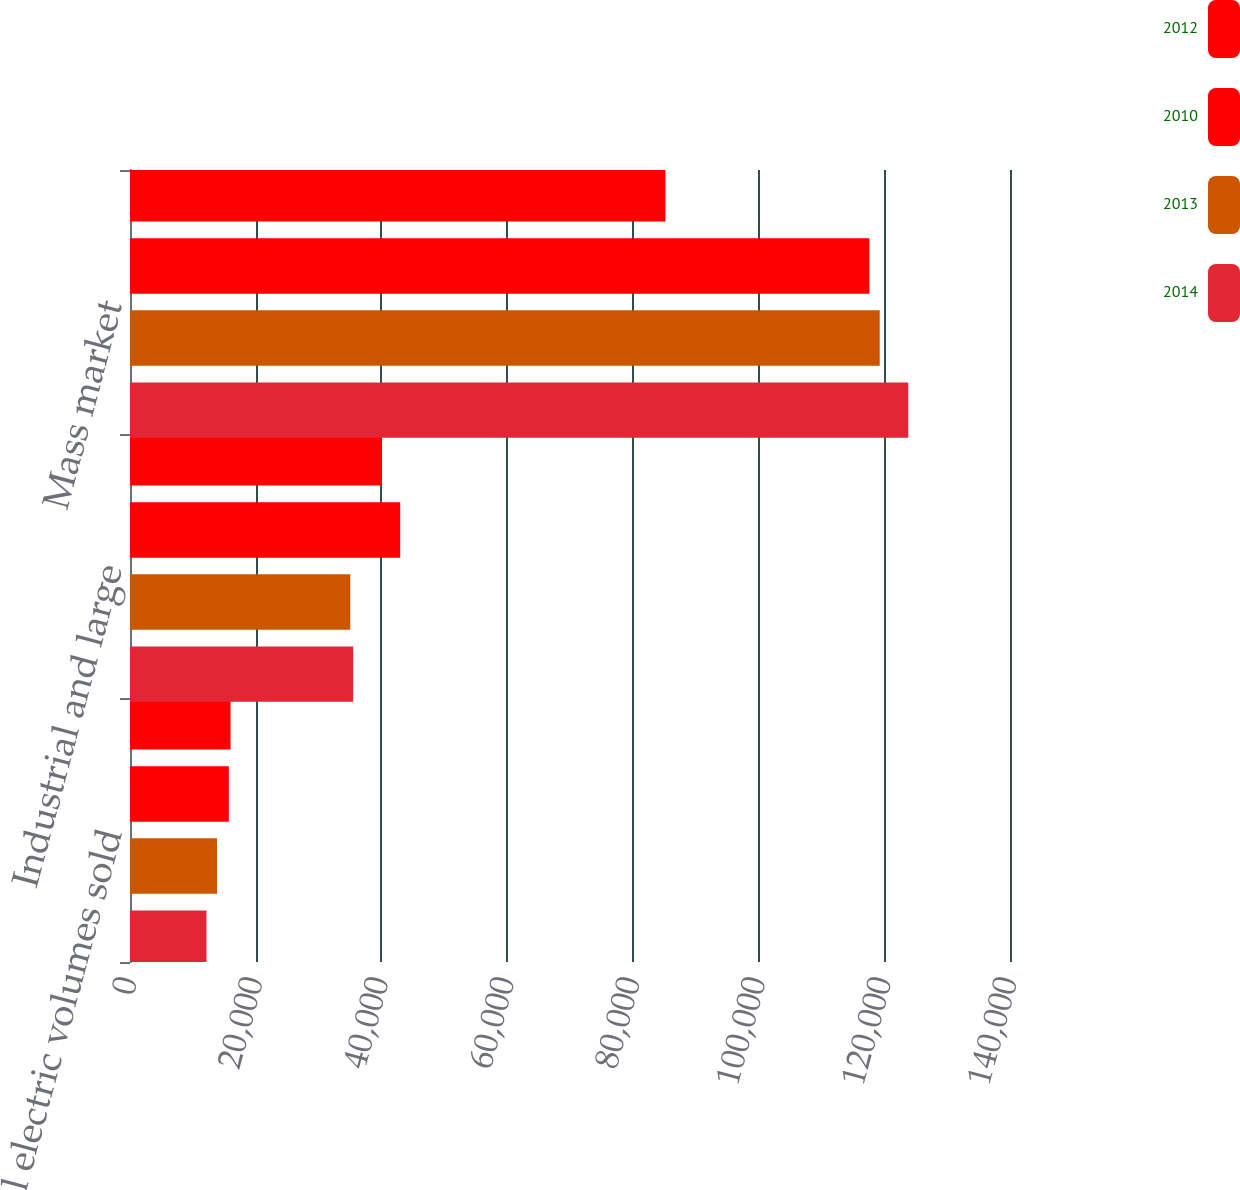Convert chart to OTSL. <chart><loc_0><loc_0><loc_500><loc_500><stacked_bar_chart><ecel><fcel>Retail electric volumes sold<fcel>Industrial and large<fcel>Mass market<nl><fcel>2012<fcel>15993<fcel>40081<fcel>85191<nl><fcel>2010<fcel>15725<fcel>42983<fcel>117635<nl><fcel>2013<fcel>13840<fcel>35043<fcel>119276<nl><fcel>2014<fcel>12167<fcel>35504<fcel>123813<nl></chart> 